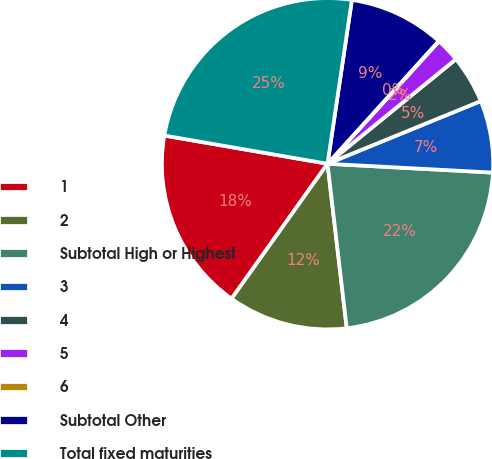Convert chart to OTSL. <chart><loc_0><loc_0><loc_500><loc_500><pie_chart><fcel>1<fcel>2<fcel>Subtotal High or Highest<fcel>3<fcel>4<fcel>5<fcel>6<fcel>Subtotal Other<fcel>Total fixed maturities<nl><fcel>17.89%<fcel>11.69%<fcel>22.3%<fcel>7.03%<fcel>4.7%<fcel>2.37%<fcel>0.04%<fcel>9.36%<fcel>24.63%<nl></chart> 